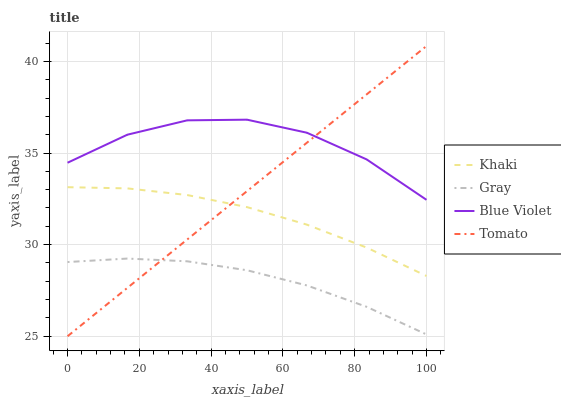Does Gray have the minimum area under the curve?
Answer yes or no. Yes. Does Blue Violet have the maximum area under the curve?
Answer yes or no. Yes. Does Khaki have the minimum area under the curve?
Answer yes or no. No. Does Khaki have the maximum area under the curve?
Answer yes or no. No. Is Tomato the smoothest?
Answer yes or no. Yes. Is Blue Violet the roughest?
Answer yes or no. Yes. Is Gray the smoothest?
Answer yes or no. No. Is Gray the roughest?
Answer yes or no. No. Does Gray have the lowest value?
Answer yes or no. No. Does Khaki have the highest value?
Answer yes or no. No. Is Khaki less than Blue Violet?
Answer yes or no. Yes. Is Khaki greater than Gray?
Answer yes or no. Yes. Does Khaki intersect Blue Violet?
Answer yes or no. No. 